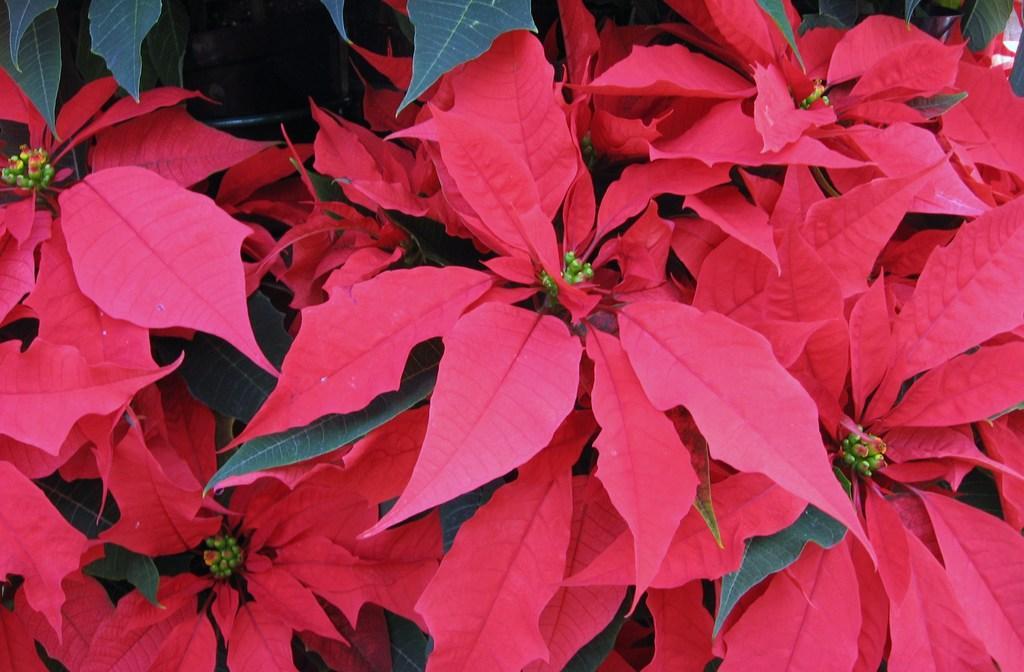Describe this image in one or two sentences. In the picture I can see leaves of plants. These leaves are green and pink in color. 